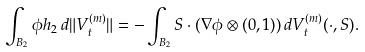Convert formula to latex. <formula><loc_0><loc_0><loc_500><loc_500>\int _ { B _ { 2 } } \phi h _ { 2 } \, d \| V _ { t } ^ { ( m ) } \| = - \int _ { B _ { 2 } } S \cdot ( \nabla \phi \otimes ( 0 , 1 ) ) \, d V _ { t } ^ { ( m ) } ( \cdot , S ) .</formula> 